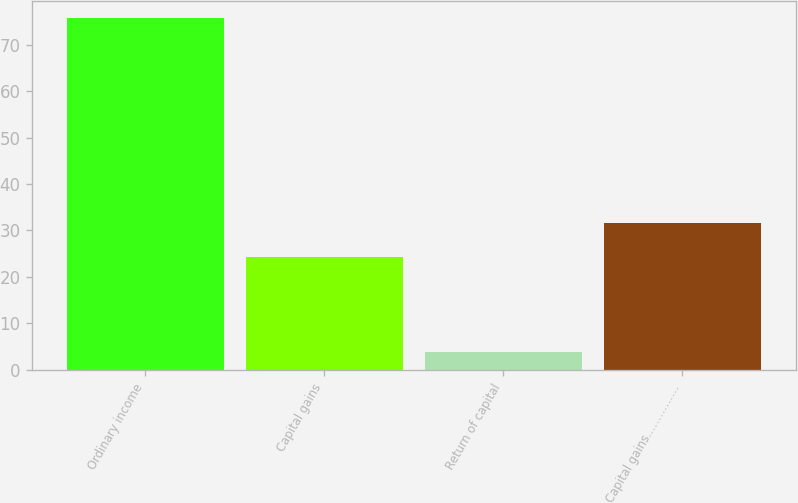Convert chart to OTSL. <chart><loc_0><loc_0><loc_500><loc_500><bar_chart><fcel>Ordinary income<fcel>Capital gains<fcel>Return of capital<fcel>Capital gains……………<nl><fcel>75.65<fcel>24.35<fcel>3.76<fcel>31.54<nl></chart> 